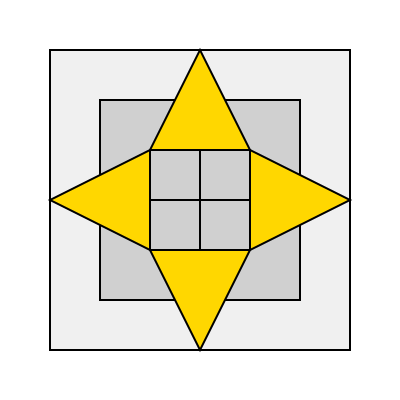Given the 3D model of a government building's roof structure shown above, which arrangement of solar panels would maximize energy production throughout the year, considering the building's orientation and potential shading? To determine the most efficient layout for solar panels on this government building, we need to consider several factors:

1. Sun path: The sun's position changes throughout the day and year, affecting the amount of sunlight each roof section receives.

2. Roof orientation: The diagram shows a symmetrical building with four distinct roof sections.

3. Potential shading: Adjacent structures or the building itself may cast shadows on certain roof sections.

4. Surface area: Larger roof sections can accommodate more solar panels.

5. Angle of inclination: The roof's pitch affects the efficiency of solar panels.

Analyzing the diagram:

a) The yellow triangles represent the roof sections.
b) The north-facing section (top) receives less direct sunlight in the northern hemisphere.
c) The east (right) and west (left) sections receive sunlight during morning and afternoon, respectively.
d) The south-facing section (bottom) receives the most consistent sunlight throughout the day.

Considering these factors:

1. The south-facing section is optimal for solar panel placement due to consistent sunlight exposure.
2. East and west sections are secondary options, providing balanced energy production throughout the day.
3. The north-facing section is least suitable due to limited direct sunlight.

To maximize energy production, the most efficient layout would be:

1. Cover the entire south-facing section with solar panels.
2. Utilize available space on east and west sections, prioritizing areas closer to the south-facing side.
3. Avoid or minimize panel placement on the north-facing section.

This arrangement ensures optimal sunlight exposure throughout the year, maximizing energy production while considering the building's orientation and potential shading issues.
Answer: South-facing section fully covered, east and west sections partially covered, north section avoided. 